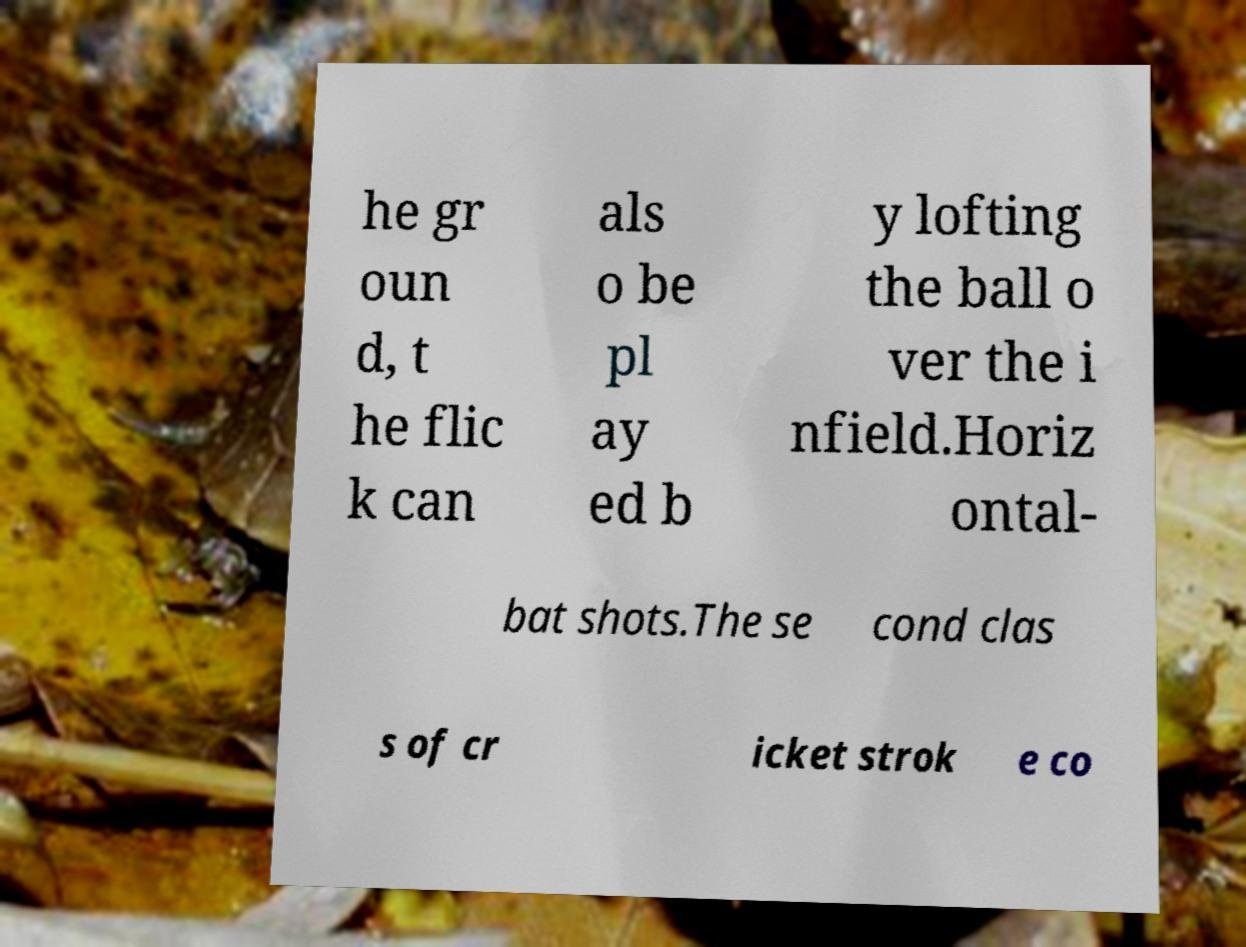I need the written content from this picture converted into text. Can you do that? he gr oun d, t he flic k can als o be pl ay ed b y lofting the ball o ver the i nfield.Horiz ontal- bat shots.The se cond clas s of cr icket strok e co 